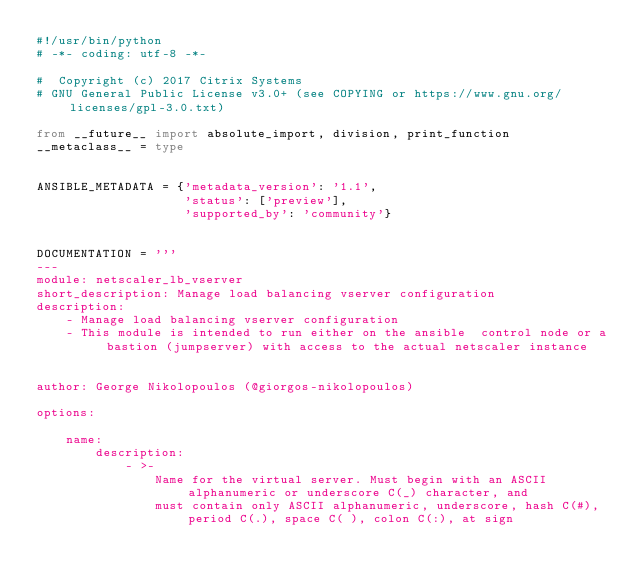<code> <loc_0><loc_0><loc_500><loc_500><_Python_>#!/usr/bin/python
# -*- coding: utf-8 -*-

#  Copyright (c) 2017 Citrix Systems
# GNU General Public License v3.0+ (see COPYING or https://www.gnu.org/licenses/gpl-3.0.txt)

from __future__ import absolute_import, division, print_function
__metaclass__ = type


ANSIBLE_METADATA = {'metadata_version': '1.1',
                    'status': ['preview'],
                    'supported_by': 'community'}


DOCUMENTATION = '''
---
module: netscaler_lb_vserver
short_description: Manage load balancing vserver configuration
description:
    - Manage load balancing vserver configuration
    - This module is intended to run either on the ansible  control node or a bastion (jumpserver) with access to the actual netscaler instance


author: George Nikolopoulos (@giorgos-nikolopoulos)

options:

    name:
        description:
            - >-
                Name for the virtual server. Must begin with an ASCII alphanumeric or underscore C(_) character, and
                must contain only ASCII alphanumeric, underscore, hash C(#), period C(.), space C( ), colon C(:), at sign</code> 